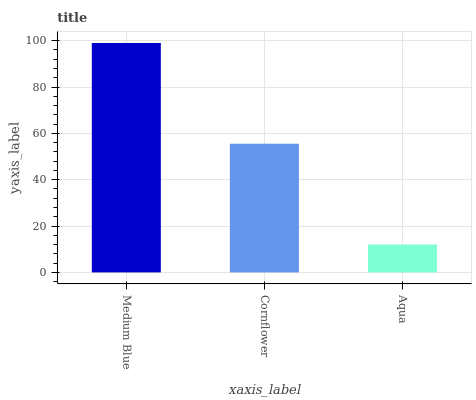Is Aqua the minimum?
Answer yes or no. Yes. Is Medium Blue the maximum?
Answer yes or no. Yes. Is Cornflower the minimum?
Answer yes or no. No. Is Cornflower the maximum?
Answer yes or no. No. Is Medium Blue greater than Cornflower?
Answer yes or no. Yes. Is Cornflower less than Medium Blue?
Answer yes or no. Yes. Is Cornflower greater than Medium Blue?
Answer yes or no. No. Is Medium Blue less than Cornflower?
Answer yes or no. No. Is Cornflower the high median?
Answer yes or no. Yes. Is Cornflower the low median?
Answer yes or no. Yes. Is Aqua the high median?
Answer yes or no. No. Is Medium Blue the low median?
Answer yes or no. No. 